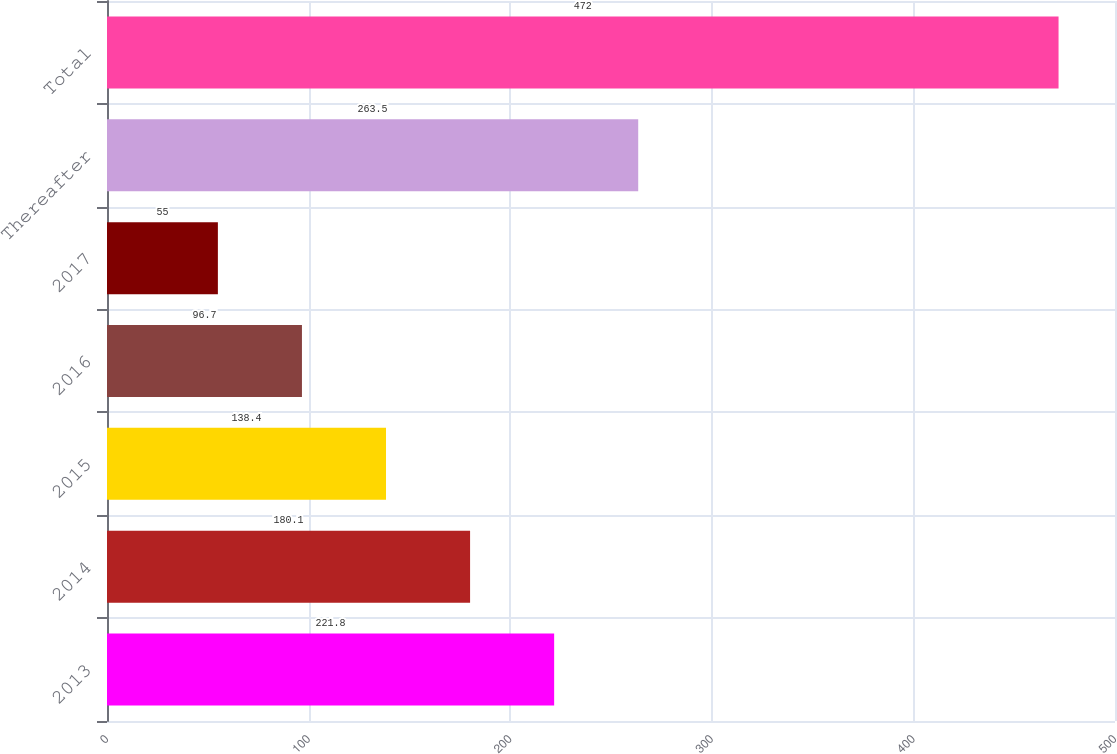Convert chart to OTSL. <chart><loc_0><loc_0><loc_500><loc_500><bar_chart><fcel>2013<fcel>2014<fcel>2015<fcel>2016<fcel>2017<fcel>Thereafter<fcel>Total<nl><fcel>221.8<fcel>180.1<fcel>138.4<fcel>96.7<fcel>55<fcel>263.5<fcel>472<nl></chart> 